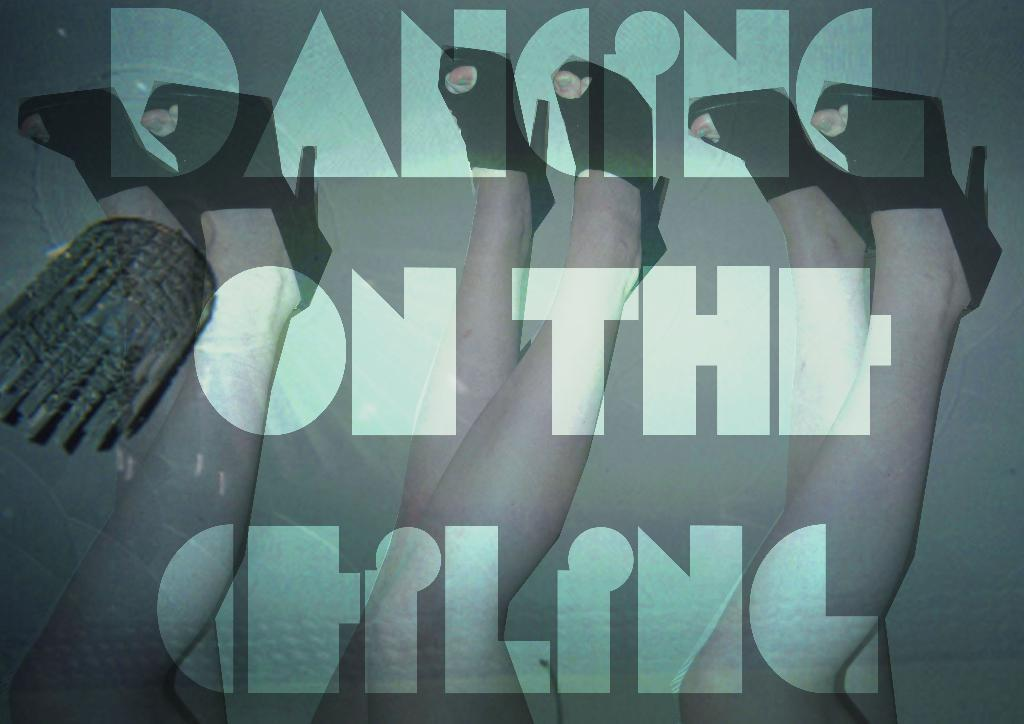What is depicted in the picture? There is a poster in the picture. What is shown on the poster? The poster features the legs of women. What are the women wearing on their feet? The women are wearing footwear. Is there any text on the poster? Yes, there is text on the poster. How many children can be seen playing in the clouds in the image? There are no children or clouds present in the image; it features a poster with the legs of women. What is the position of the women in the image? The position of the women cannot be determined from the image, as only their legs are visible. 